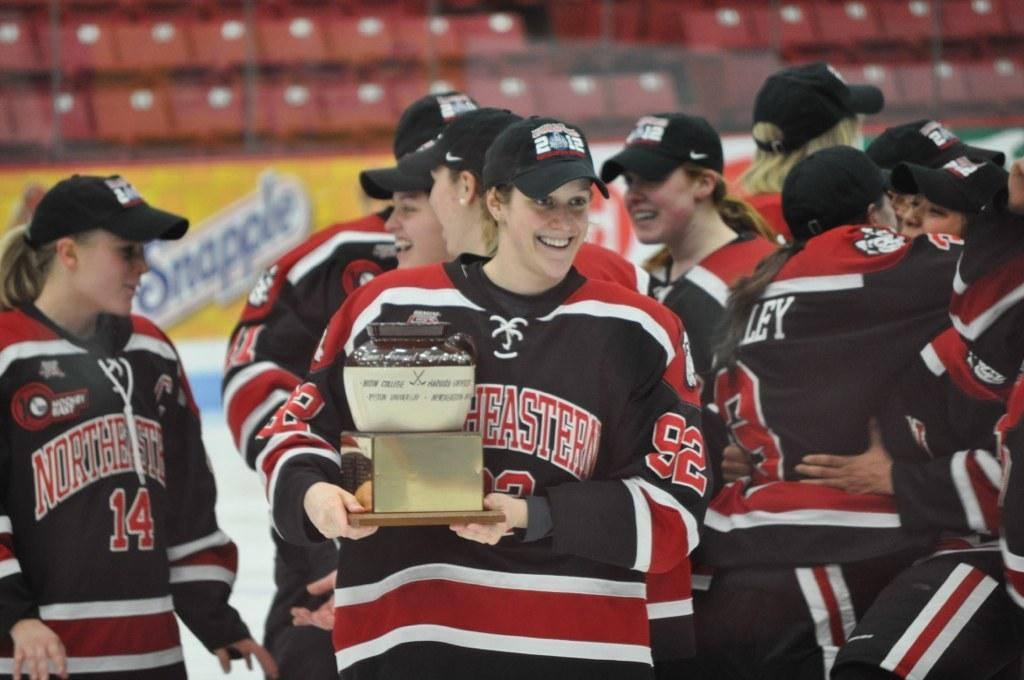<image>
Summarize the visual content of the image. The team celebrating a win is the Northeastern 